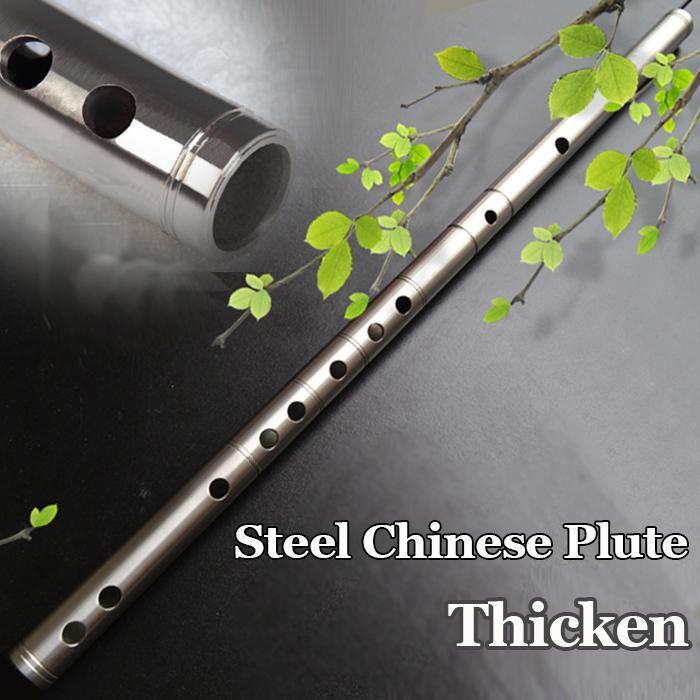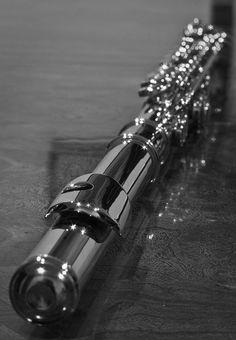The first image is the image on the left, the second image is the image on the right. Evaluate the accuracy of this statement regarding the images: "There are more than three flutes.". Is it true? Answer yes or no. No. The first image is the image on the left, the second image is the image on the right. For the images displayed, is the sentence "The left image contains at least three flute like musical instruments." factually correct? Answer yes or no. No. 